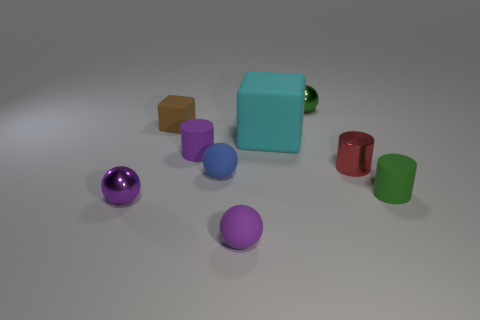How many matte objects are small purple cylinders or small green things?
Provide a short and direct response. 2. What number of things are in front of the green shiny thing and behind the red metallic cylinder?
Ensure brevity in your answer.  3. Is there anything else that has the same shape as the small brown thing?
Your response must be concise. Yes. How many other things are the same size as the brown block?
Offer a terse response. 7. Do the rubber object that is behind the cyan thing and the green object in front of the green ball have the same size?
Your answer should be very brief. Yes. What number of things are small brown rubber objects or purple balls to the left of the brown object?
Offer a terse response. 2. What is the size of the purple sphere that is to the left of the blue matte thing?
Ensure brevity in your answer.  Small. Is the number of blue balls behind the red object less than the number of small cylinders that are behind the small green rubber cylinder?
Offer a terse response. Yes. The tiny thing that is behind the purple matte cylinder and on the right side of the brown block is made of what material?
Your answer should be very brief. Metal. What is the shape of the matte object in front of the metallic sphere left of the large matte object?
Keep it short and to the point. Sphere. 